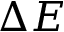Convert formula to latex. <formula><loc_0><loc_0><loc_500><loc_500>\Delta E</formula> 